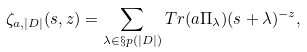<formula> <loc_0><loc_0><loc_500><loc_500>\zeta _ { a , | D | } ( s , z ) = \sum _ { \lambda \in \S p ( | D | ) } T r ( a \Pi _ { \lambda } ) ( s + \lambda ) ^ { - z } ,</formula> 